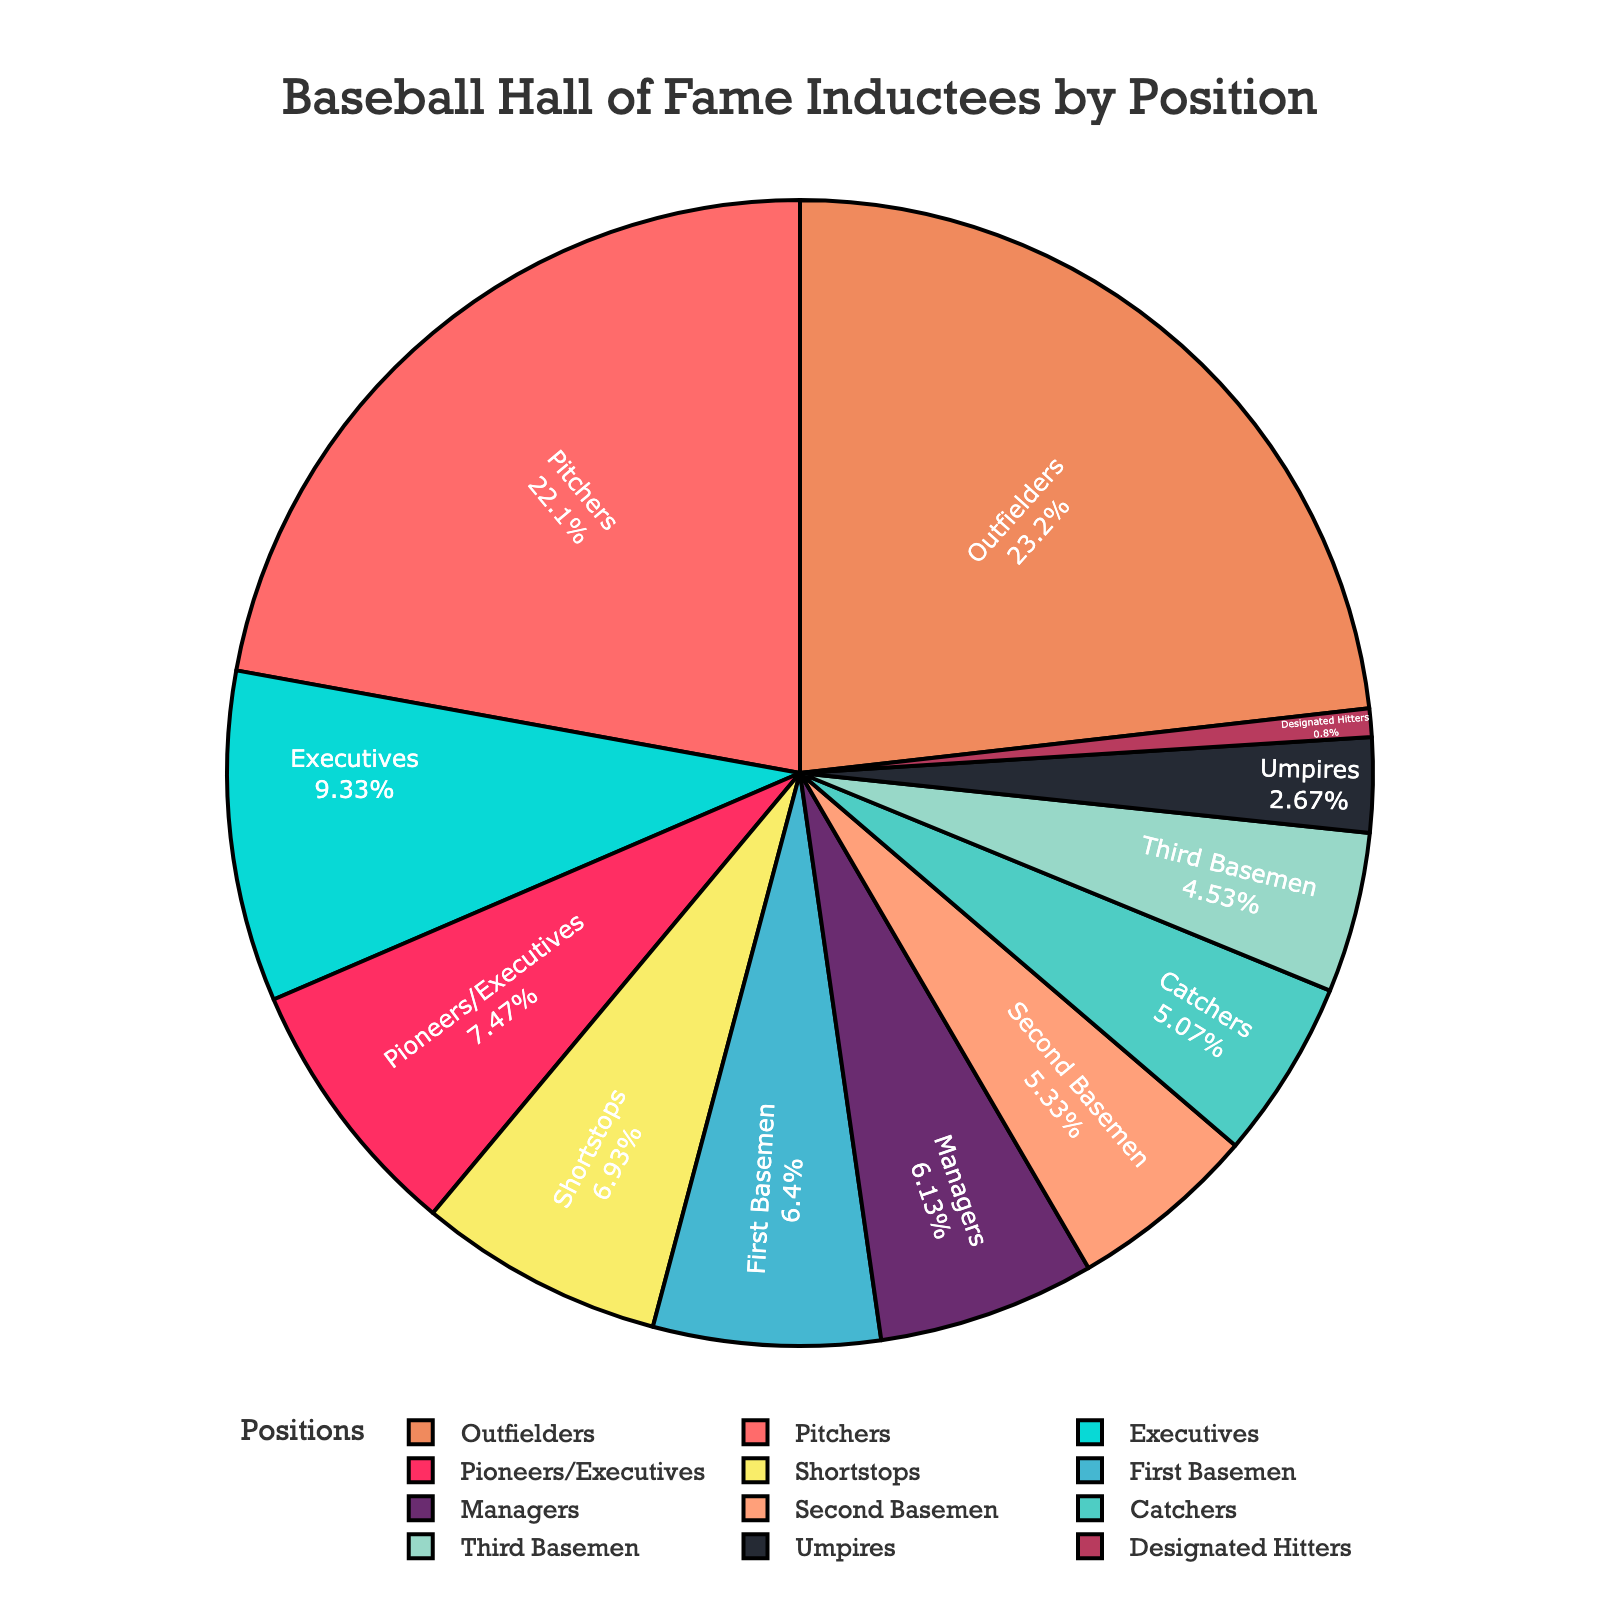What is the largest group of inductees by position? Looking at the pie chart, the largest segment represents the group with the most inductees. The “Outfielders” category has the largest segment in the chart.
Answer: Outfielders Which position has fewer inductees, Catchers or First Basemen? By comparing the sizes of the segments for “Catchers” and “First Basemen” on the pie chart, the “Catchers” segment is smaller.
Answer: Catchers What proportion of inductees are Pitchers? Find the portion of the pie chart labeled “Pitchers” and read the percentage displayed inside or associated with that segment.
Answer: 23% How many more inductees are there for Executives than Managers? Compare the number of inductees for “Executives” and “Managers” from the data. Executives have 35, Managers have 23. Calculating the difference: 35 - 23 = 12.
Answer: 12 What's the combined percentage for Umpires and Designated Hitters? Read the percentages for "Umpires" and "Designated Hitters" from the pie chart then sum them up. Umpires are 2.8% and Designated Hitters are 0.8%. So, 2.8% + 0.8% = 3.6%.
Answer: 3.6% Is the number of Shortstops greater than the number of Second Basemen? Compare the number of inductees for “Shortstops” and “Second Basemen”. Shortstops have 26, and Second Basemen have 20. Hence, the number of Shortstops is greater.
Answer: Yes Which group has the smallest representation in the Hall of Fame? Identify the smallest segment on the pie chart. The “Designated Hitters” category has the smallest segment.
Answer: Designated Hitters What color represents the Third Basemen on the chart? Find the segment labeled “Third Basemen” and note its color.
Answer: Pink How many more Outfielders are there than Pitchers? Compare the number of inductees for “Outfielders” (87) and “Pitchers” (83). Calculate the difference: 87 - 83 = 4.
Answer: 4 What is the combined total of inductees for Infielders (First Basemen, Second Basemen, Third Basemen, and Shortstops)? Sum the number of inductees for “First Basemen” (24), “Second Basemen” (20), “Third Basemen” (17), and “Shortstops” (26). Calculate: 24 + 20 + 17 + 26 = 87.
Answer: 87 